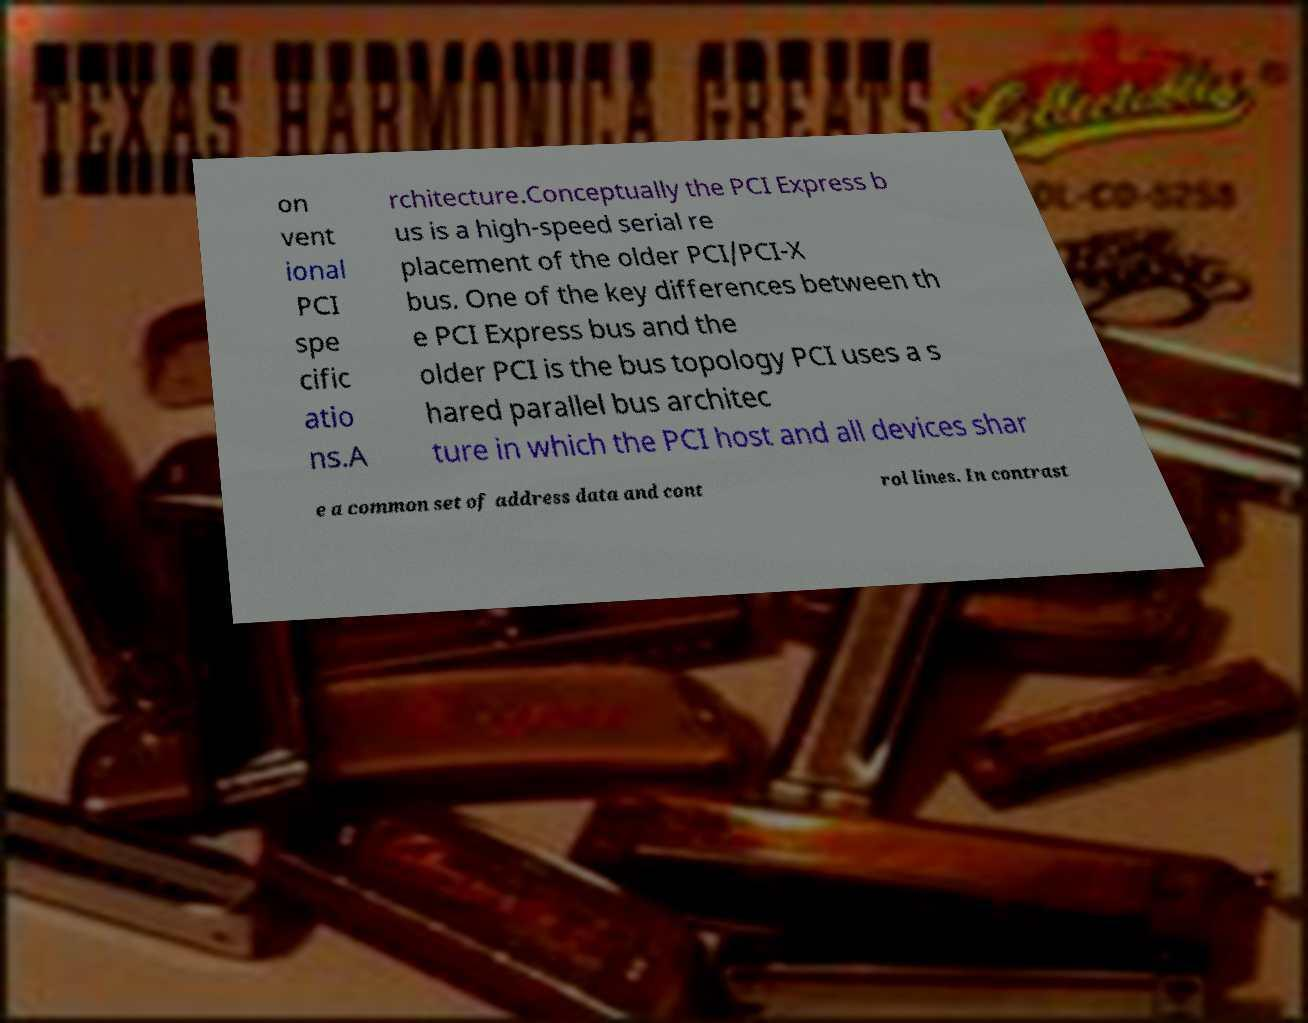I need the written content from this picture converted into text. Can you do that? on vent ional PCI spe cific atio ns.A rchitecture.Conceptually the PCI Express b us is a high-speed serial re placement of the older PCI/PCI-X bus. One of the key differences between th e PCI Express bus and the older PCI is the bus topology PCI uses a s hared parallel bus architec ture in which the PCI host and all devices shar e a common set of address data and cont rol lines. In contrast 